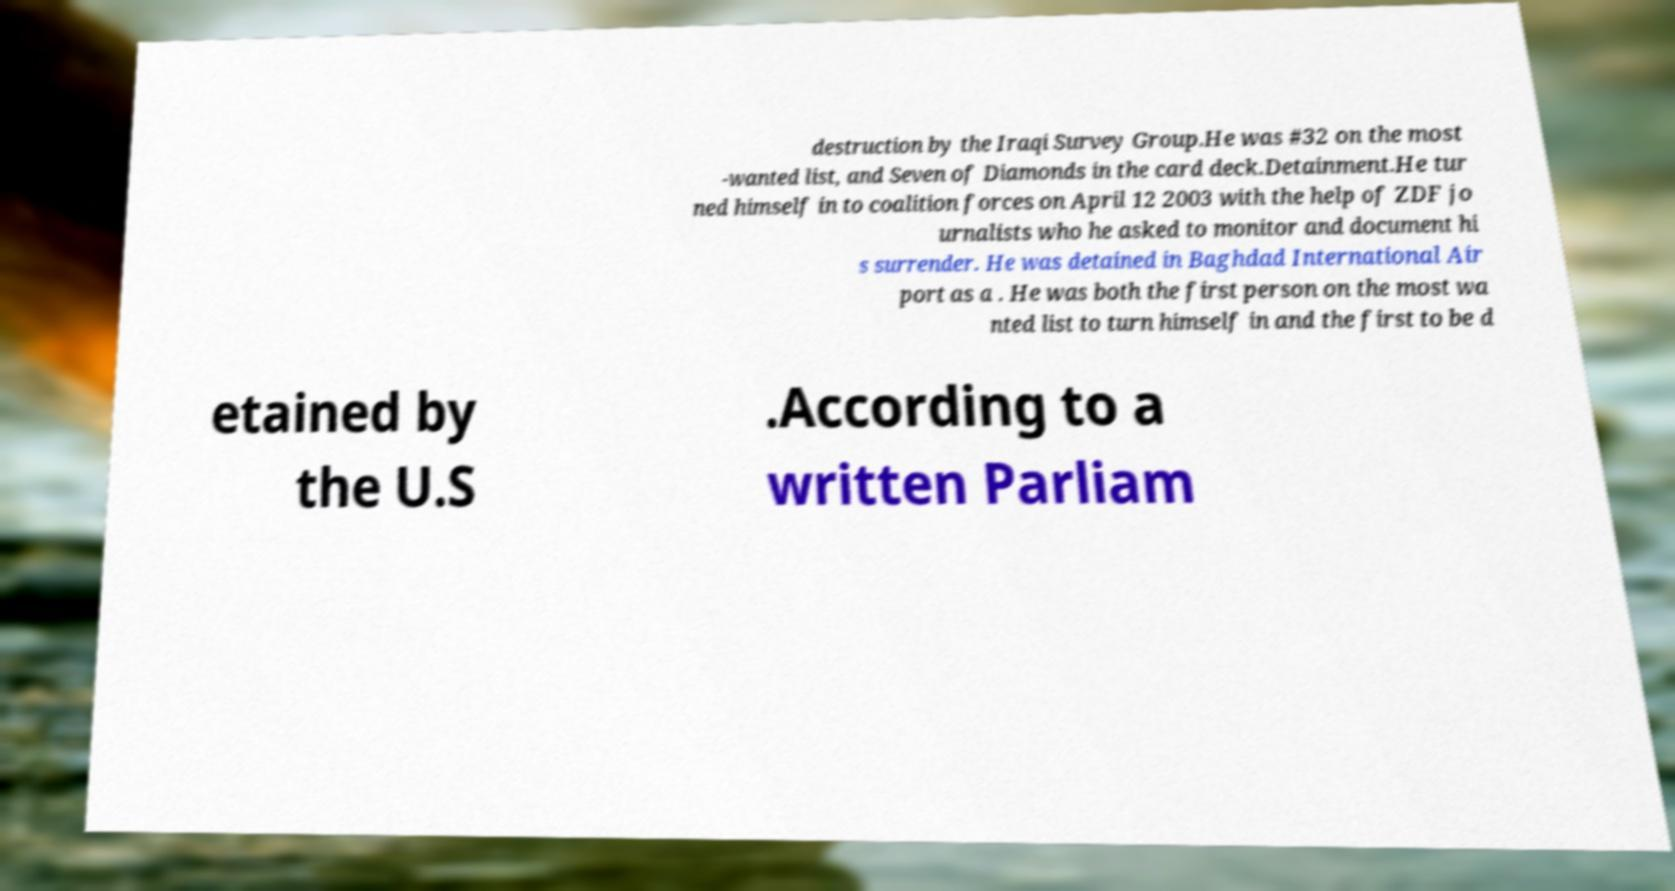Please read and relay the text visible in this image. What does it say? destruction by the Iraqi Survey Group.He was #32 on the most -wanted list, and Seven of Diamonds in the card deck.Detainment.He tur ned himself in to coalition forces on April 12 2003 with the help of ZDF jo urnalists who he asked to monitor and document hi s surrender. He was detained in Baghdad International Air port as a . He was both the first person on the most wa nted list to turn himself in and the first to be d etained by the U.S .According to a written Parliam 